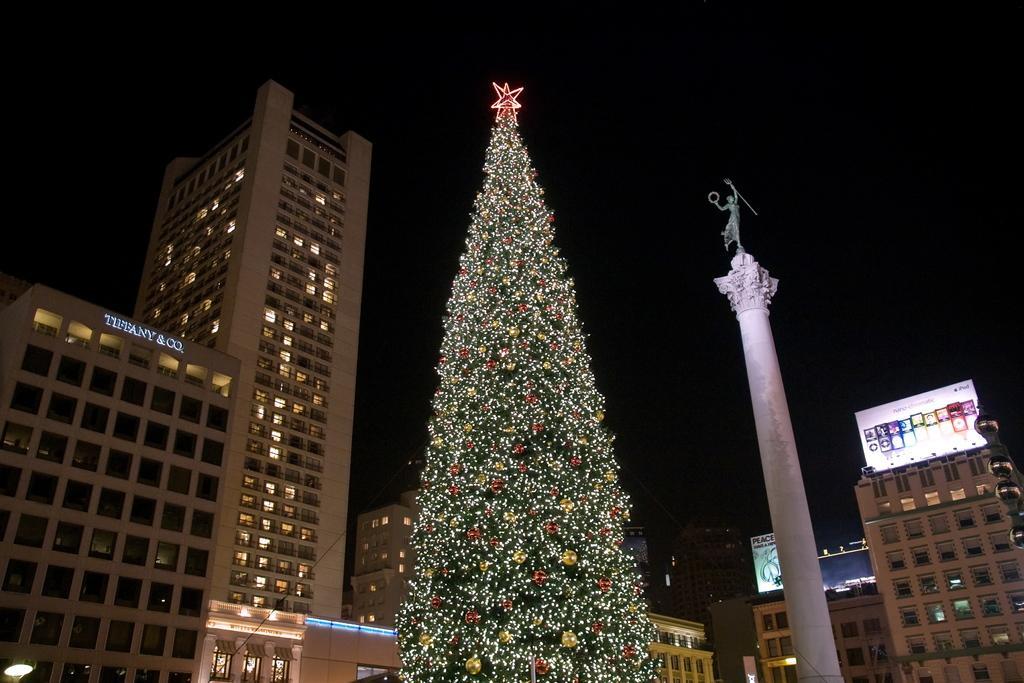In one or two sentences, can you explain what this image depicts? In this picture we can see a Christmas tree, pillar, statue, banners, lights, buildings with windows and in the background it is dark. 